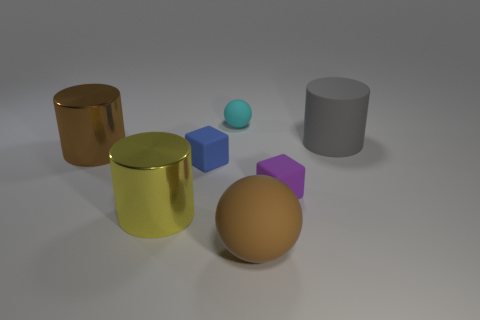Subtract all big metal cylinders. How many cylinders are left? 1 Subtract all brown cylinders. How many cylinders are left? 2 Subtract 1 cylinders. How many cylinders are left? 2 Add 3 tiny cyan spheres. How many objects exist? 10 Subtract all green metallic cylinders. Subtract all large yellow things. How many objects are left? 6 Add 2 brown metallic cylinders. How many brown metallic cylinders are left? 3 Add 2 cyan things. How many cyan things exist? 3 Subtract 0 gray cubes. How many objects are left? 7 Subtract all cubes. How many objects are left? 5 Subtract all cyan cubes. Subtract all blue cylinders. How many cubes are left? 2 